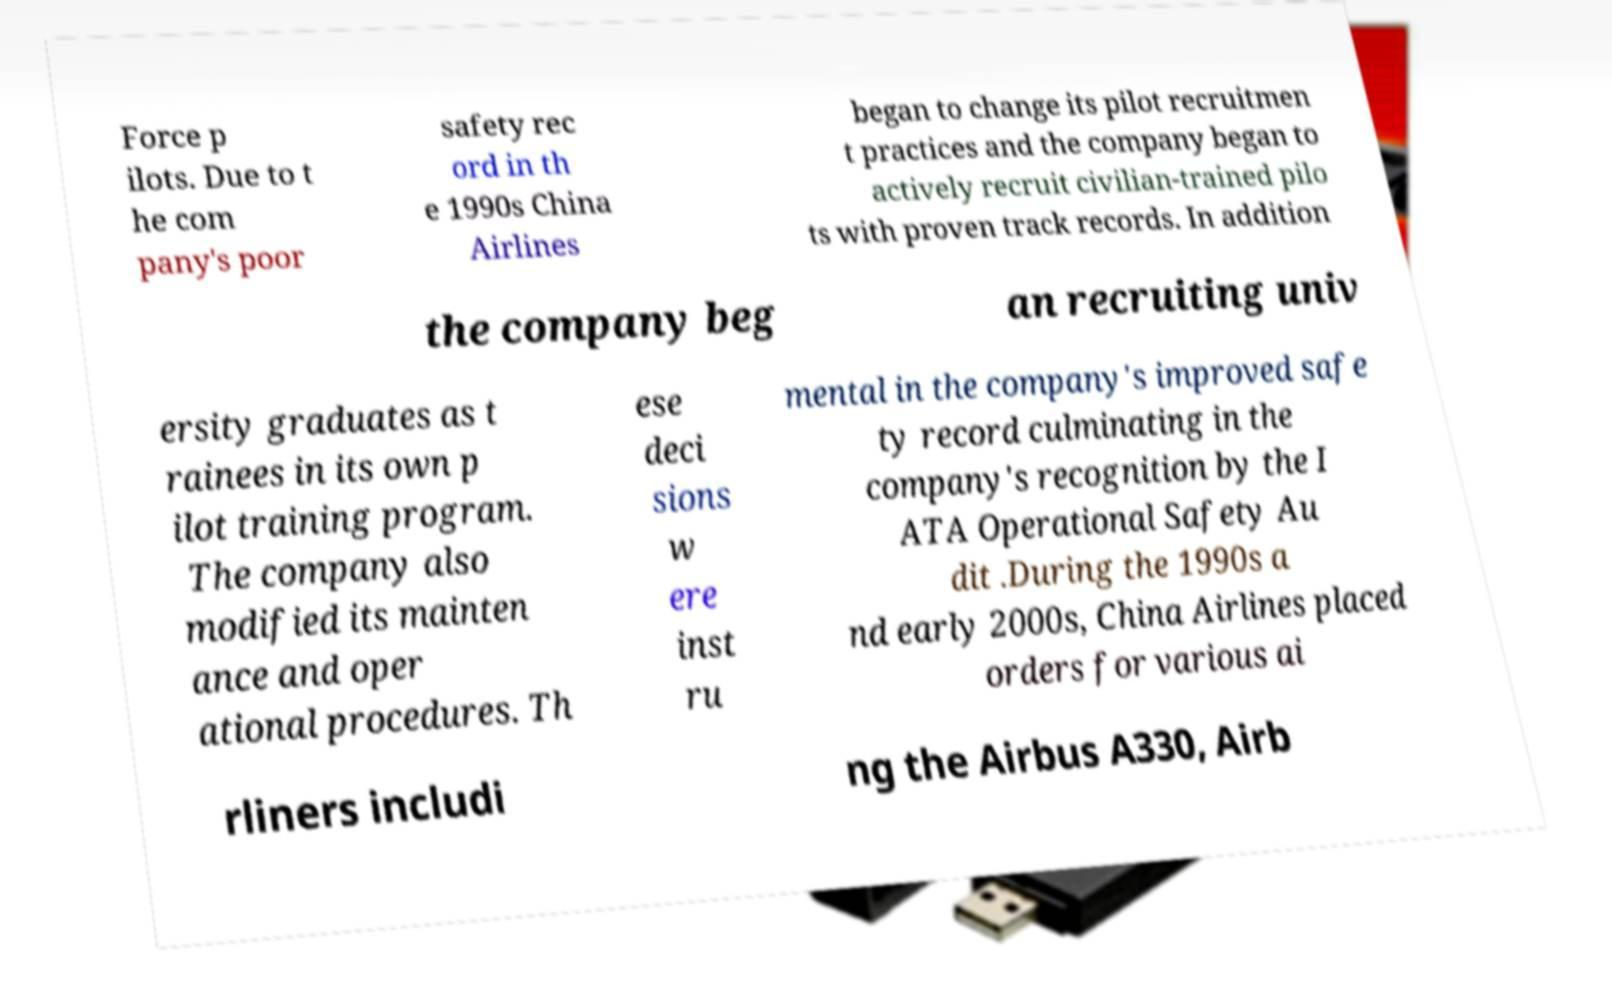I need the written content from this picture converted into text. Can you do that? Force p ilots. Due to t he com pany's poor safety rec ord in th e 1990s China Airlines began to change its pilot recruitmen t practices and the company began to actively recruit civilian-trained pilo ts with proven track records. In addition the company beg an recruiting univ ersity graduates as t rainees in its own p ilot training program. The company also modified its mainten ance and oper ational procedures. Th ese deci sions w ere inst ru mental in the company's improved safe ty record culminating in the company's recognition by the I ATA Operational Safety Au dit .During the 1990s a nd early 2000s, China Airlines placed orders for various ai rliners includi ng the Airbus A330, Airb 